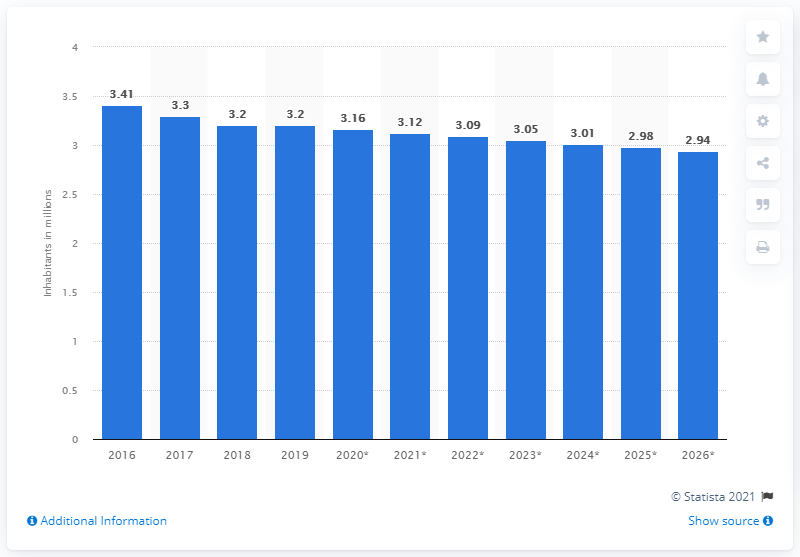Mention a couple of crucial points in this snapshot. The population of Puerto Rico in 2019 was 3.2 million. 